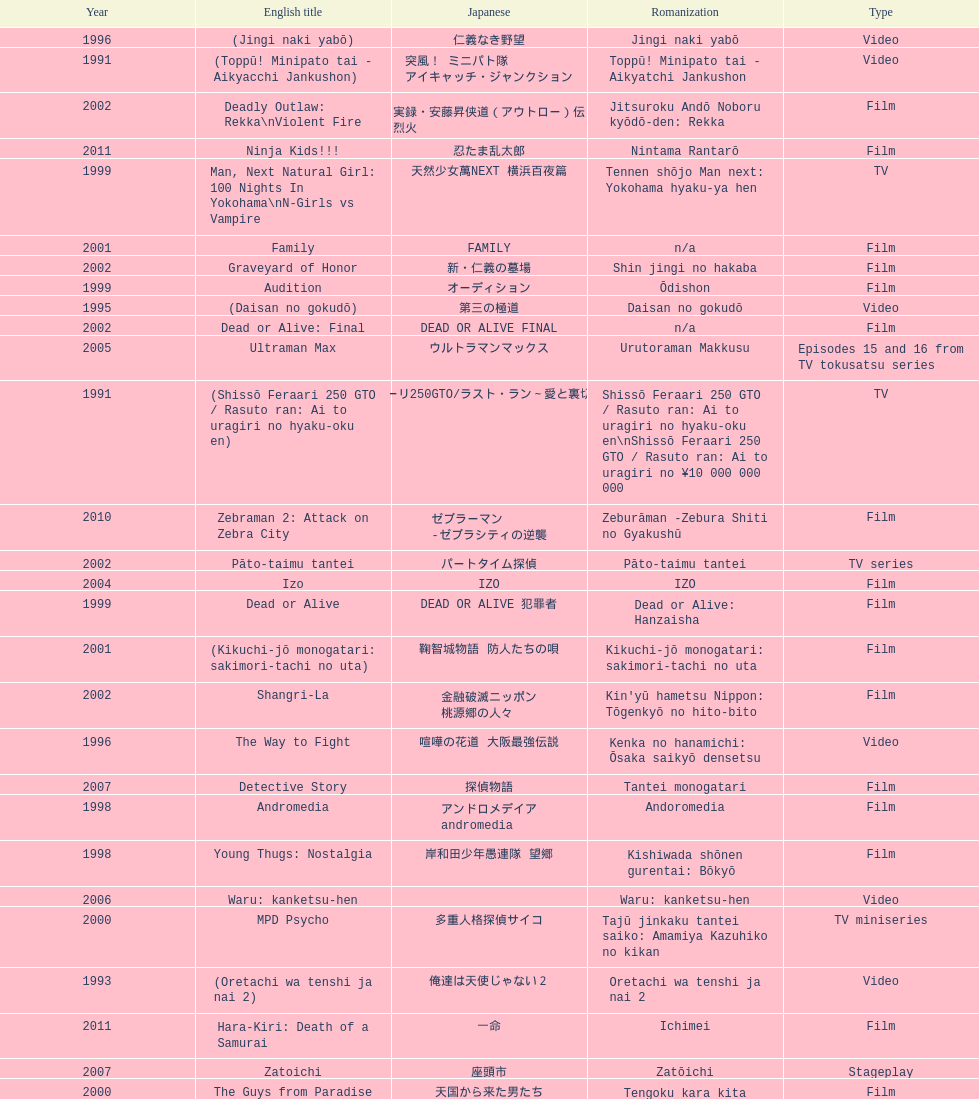Were more air on tv or video? Video. 